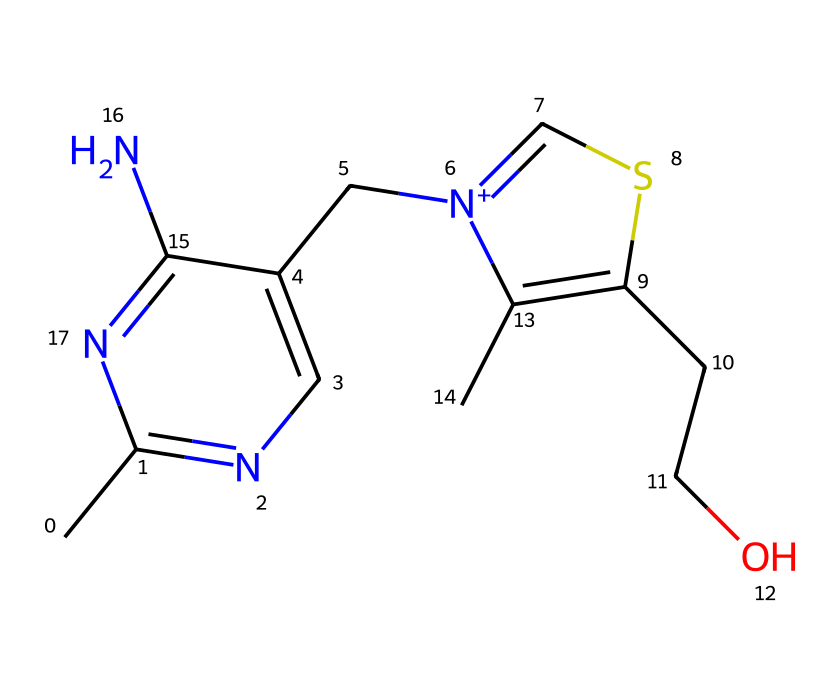What is the molecular formula of thiamine? To determine the molecular formula from the SMILES representation, we identify the types and counts of each atom present in the structure: carbon (C), hydrogen (H), nitrogen (N), oxygen (O), and sulfur (S). Counting these, we find 12 carbons, 17 hydrogens, 4 nitrogens, 1 oxygen, and 1 sulfur. This gives the molecular formula C12H17N4OS.
Answer: C12H17N4OS How many nitrogen atoms are present in thiamine? By analyzing the structural representation, we can count the number of nitrogen atoms directly from the SMILES notation, which shows four 'n' and '[n+]'. This indicates that there are a total of 4 nitrogen atoms in the thiamine structure.
Answer: 4 What type of chemical bond connects the sulfur atom in thiamine? The SMILES structure includes the sulfur atom (represented in the notation) bonded to two carbon atoms. There are simple single bonds indicated by the connectivity. This shows that the sulfur atom is linked through single covalent bonds.
Answer: single covalent bond Which functional group is crucial for the biological activity of thiamine? Upon examining the structure, the thiazole ring is essential for thiamine's biological function. The ring contains sulfur and nitrogen, making this group important for binding to enzymes and playing a role in carbohydrate metabolism.
Answer: thiazole ring Is thiamine a hydrophilic or hydrophobic compound? The presence of the hydroxymethyl group (CCO) in thiamine indicates that it has groups that can form hydrogen bonds with water, which makes it more hydrophilic. Additionally, organic compounds with such groups tend to have a better solubility in water.
Answer: hydrophilic 